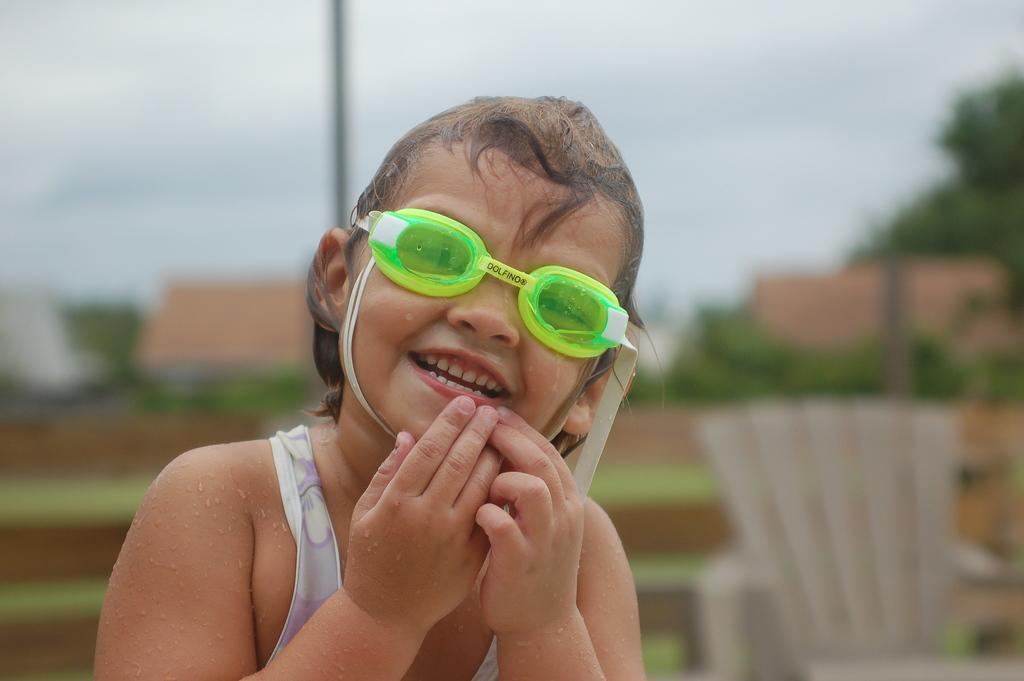Who is the main subject in the image? There is a girl in the image. What is the girl doing in the image? The girl is standing. What accessory is the girl wearing in the image? The girl is wearing glasses. Can you describe the background of the image? The background of the image is blurred. How many cats are helping the girl in the image? There are no cats present in the image, and therefore no assistance from cats can be observed. 